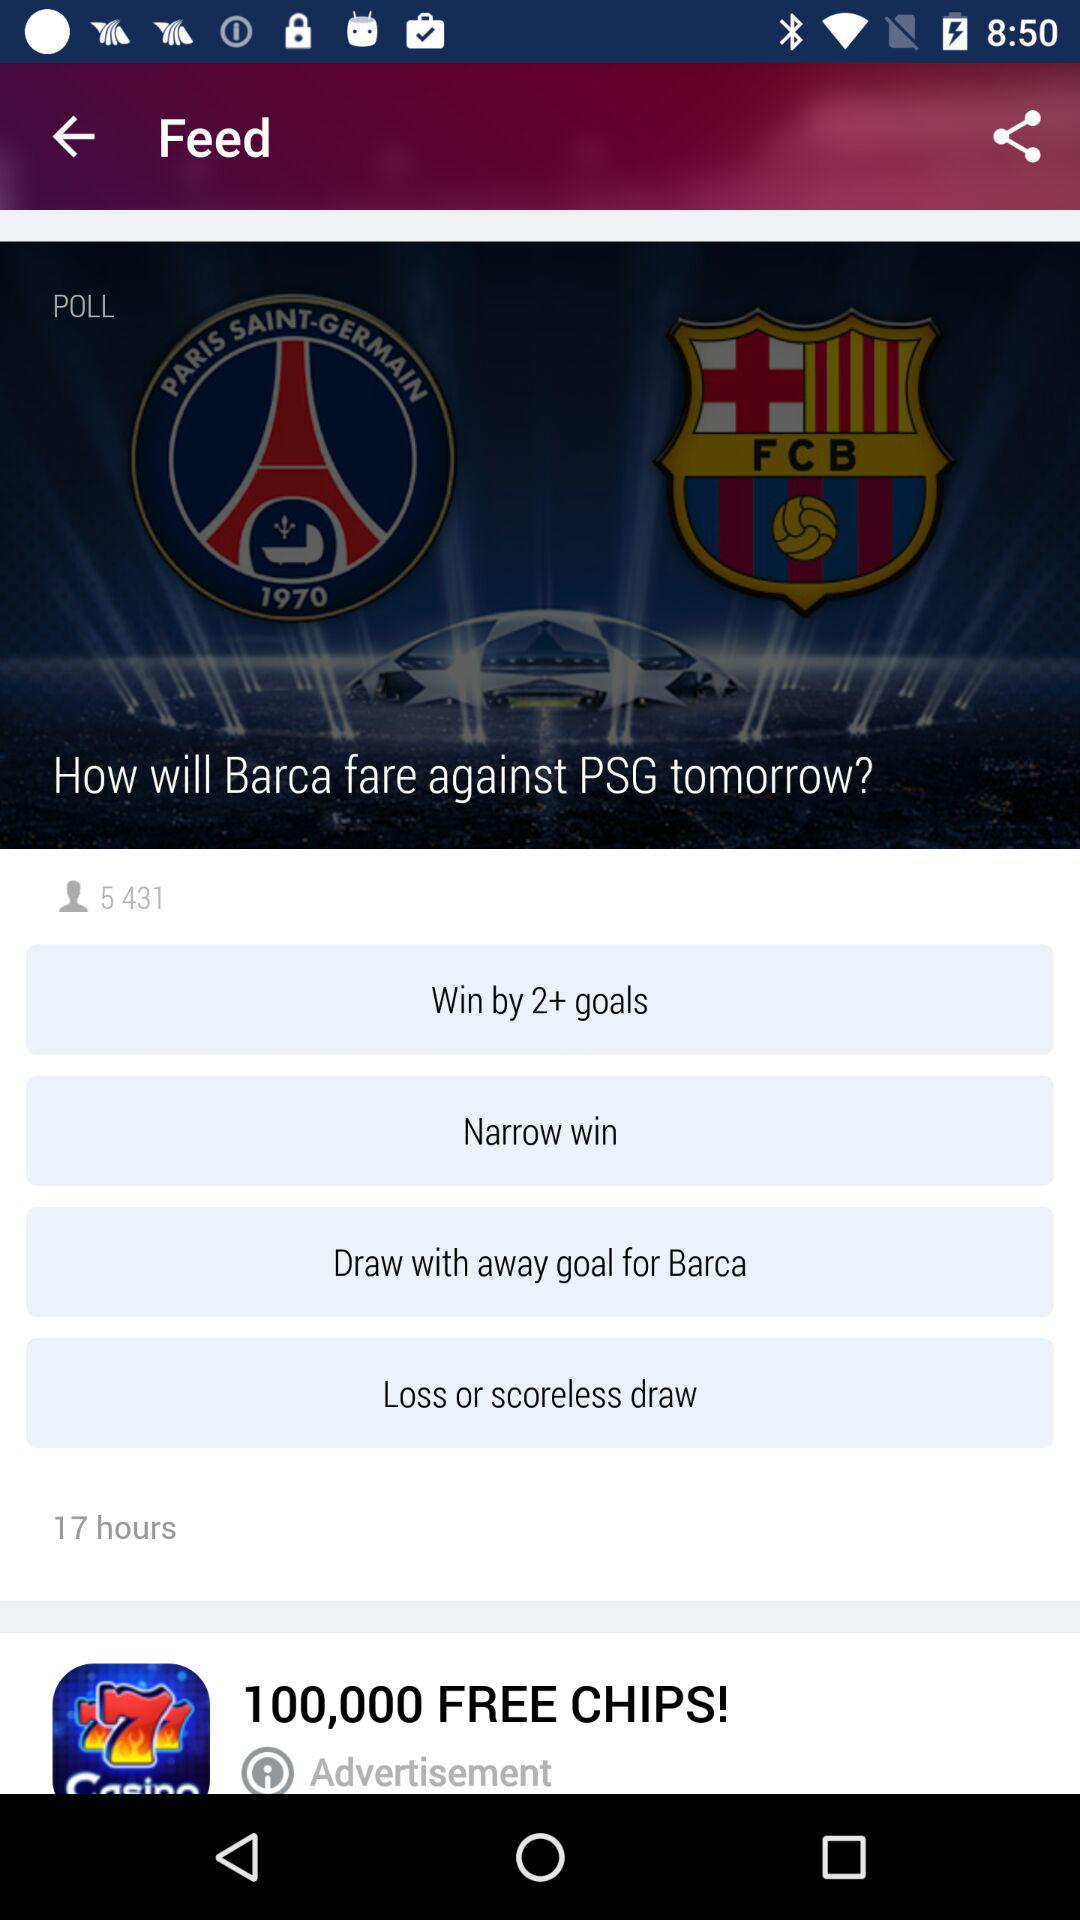When was the feed published? The feed was published 17 hours ago. 